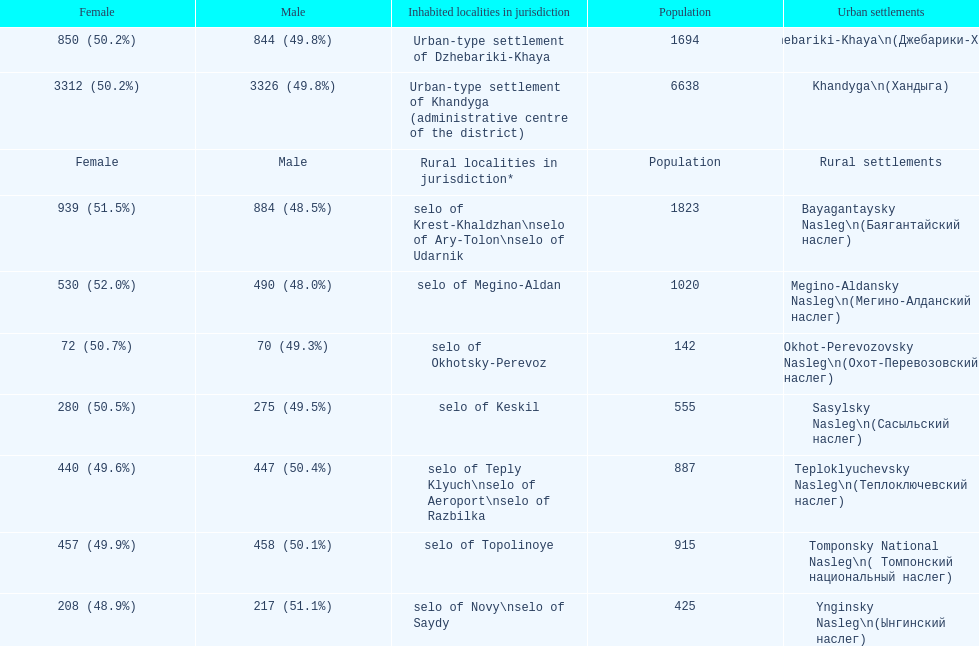What is the total population in dzhebariki-khaya? 1694. 